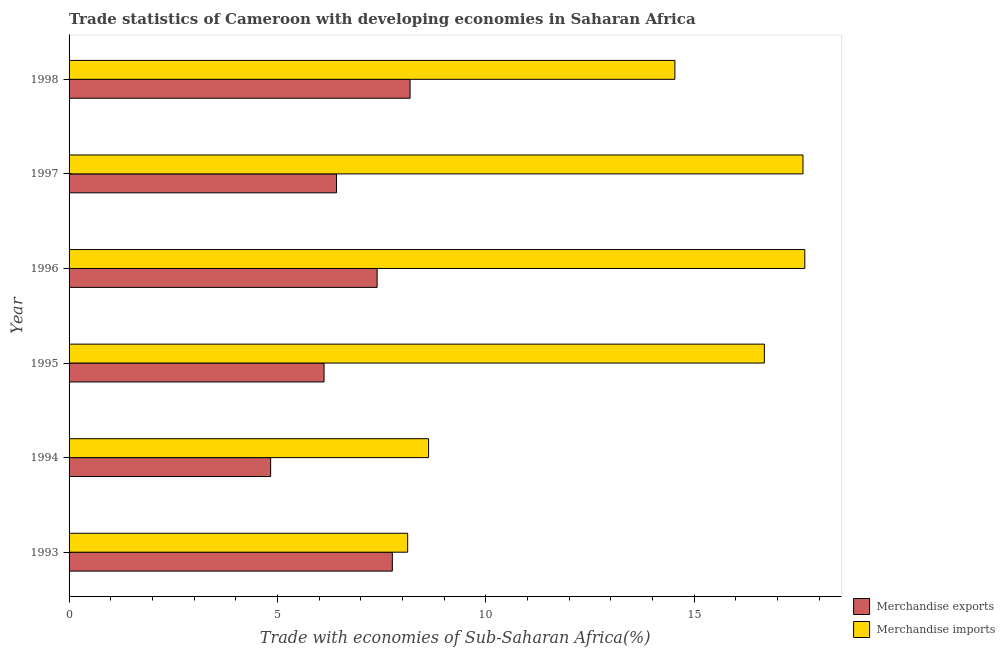How many different coloured bars are there?
Offer a very short reply. 2. How many groups of bars are there?
Ensure brevity in your answer.  6. Are the number of bars per tick equal to the number of legend labels?
Offer a very short reply. Yes. Are the number of bars on each tick of the Y-axis equal?
Provide a short and direct response. Yes. What is the label of the 2nd group of bars from the top?
Your answer should be very brief. 1997. In how many cases, is the number of bars for a given year not equal to the number of legend labels?
Keep it short and to the point. 0. What is the merchandise imports in 1998?
Offer a terse response. 14.53. Across all years, what is the maximum merchandise imports?
Your response must be concise. 17.65. Across all years, what is the minimum merchandise imports?
Your answer should be compact. 8.12. In which year was the merchandise exports minimum?
Keep it short and to the point. 1994. What is the total merchandise imports in the graph?
Keep it short and to the point. 83.23. What is the difference between the merchandise exports in 1996 and that in 1998?
Give a very brief answer. -0.79. What is the difference between the merchandise exports in 1993 and the merchandise imports in 1994?
Your answer should be very brief. -0.87. What is the average merchandise imports per year?
Your answer should be compact. 13.87. In the year 1995, what is the difference between the merchandise imports and merchandise exports?
Make the answer very short. 10.56. In how many years, is the merchandise imports greater than 15 %?
Your answer should be compact. 3. What is the ratio of the merchandise imports in 1997 to that in 1998?
Offer a very short reply. 1.21. Is the merchandise exports in 1993 less than that in 1994?
Ensure brevity in your answer.  No. Is the difference between the merchandise exports in 1995 and 1996 greater than the difference between the merchandise imports in 1995 and 1996?
Provide a succinct answer. No. What is the difference between the highest and the second highest merchandise exports?
Your response must be concise. 0.43. What is the difference between the highest and the lowest merchandise exports?
Keep it short and to the point. 3.35. In how many years, is the merchandise exports greater than the average merchandise exports taken over all years?
Ensure brevity in your answer.  3. What does the 1st bar from the top in 1998 represents?
Provide a short and direct response. Merchandise imports. What does the 2nd bar from the bottom in 1996 represents?
Keep it short and to the point. Merchandise imports. Are all the bars in the graph horizontal?
Your response must be concise. Yes. How many legend labels are there?
Your answer should be compact. 2. What is the title of the graph?
Your answer should be very brief. Trade statistics of Cameroon with developing economies in Saharan Africa. Does "Attending school" appear as one of the legend labels in the graph?
Provide a succinct answer. No. What is the label or title of the X-axis?
Ensure brevity in your answer.  Trade with economies of Sub-Saharan Africa(%). What is the Trade with economies of Sub-Saharan Africa(%) in Merchandise exports in 1993?
Ensure brevity in your answer.  7.76. What is the Trade with economies of Sub-Saharan Africa(%) in Merchandise imports in 1993?
Your response must be concise. 8.12. What is the Trade with economies of Sub-Saharan Africa(%) of Merchandise exports in 1994?
Offer a very short reply. 4.84. What is the Trade with economies of Sub-Saharan Africa(%) of Merchandise imports in 1994?
Your response must be concise. 8.63. What is the Trade with economies of Sub-Saharan Africa(%) in Merchandise exports in 1995?
Offer a terse response. 6.12. What is the Trade with economies of Sub-Saharan Africa(%) of Merchandise imports in 1995?
Make the answer very short. 16.68. What is the Trade with economies of Sub-Saharan Africa(%) in Merchandise exports in 1996?
Provide a short and direct response. 7.39. What is the Trade with economies of Sub-Saharan Africa(%) in Merchandise imports in 1996?
Provide a succinct answer. 17.65. What is the Trade with economies of Sub-Saharan Africa(%) of Merchandise exports in 1997?
Provide a short and direct response. 6.42. What is the Trade with economies of Sub-Saharan Africa(%) in Merchandise imports in 1997?
Provide a short and direct response. 17.61. What is the Trade with economies of Sub-Saharan Africa(%) in Merchandise exports in 1998?
Offer a terse response. 8.18. What is the Trade with economies of Sub-Saharan Africa(%) in Merchandise imports in 1998?
Offer a terse response. 14.53. Across all years, what is the maximum Trade with economies of Sub-Saharan Africa(%) in Merchandise exports?
Offer a terse response. 8.18. Across all years, what is the maximum Trade with economies of Sub-Saharan Africa(%) in Merchandise imports?
Offer a very short reply. 17.65. Across all years, what is the minimum Trade with economies of Sub-Saharan Africa(%) in Merchandise exports?
Your response must be concise. 4.84. Across all years, what is the minimum Trade with economies of Sub-Saharan Africa(%) in Merchandise imports?
Your answer should be compact. 8.12. What is the total Trade with economies of Sub-Saharan Africa(%) in Merchandise exports in the graph?
Your answer should be very brief. 40.7. What is the total Trade with economies of Sub-Saharan Africa(%) in Merchandise imports in the graph?
Provide a short and direct response. 83.23. What is the difference between the Trade with economies of Sub-Saharan Africa(%) of Merchandise exports in 1993 and that in 1994?
Your answer should be compact. 2.92. What is the difference between the Trade with economies of Sub-Saharan Africa(%) in Merchandise imports in 1993 and that in 1994?
Offer a terse response. -0.5. What is the difference between the Trade with economies of Sub-Saharan Africa(%) of Merchandise exports in 1993 and that in 1995?
Provide a short and direct response. 1.64. What is the difference between the Trade with economies of Sub-Saharan Africa(%) of Merchandise imports in 1993 and that in 1995?
Provide a short and direct response. -8.56. What is the difference between the Trade with economies of Sub-Saharan Africa(%) in Merchandise exports in 1993 and that in 1996?
Provide a short and direct response. 0.37. What is the difference between the Trade with economies of Sub-Saharan Africa(%) in Merchandise imports in 1993 and that in 1996?
Give a very brief answer. -9.53. What is the difference between the Trade with economies of Sub-Saharan Africa(%) in Merchandise exports in 1993 and that in 1997?
Offer a very short reply. 1.34. What is the difference between the Trade with economies of Sub-Saharan Africa(%) in Merchandise imports in 1993 and that in 1997?
Give a very brief answer. -9.48. What is the difference between the Trade with economies of Sub-Saharan Africa(%) of Merchandise exports in 1993 and that in 1998?
Keep it short and to the point. -0.43. What is the difference between the Trade with economies of Sub-Saharan Africa(%) in Merchandise imports in 1993 and that in 1998?
Provide a succinct answer. -6.41. What is the difference between the Trade with economies of Sub-Saharan Africa(%) in Merchandise exports in 1994 and that in 1995?
Offer a very short reply. -1.28. What is the difference between the Trade with economies of Sub-Saharan Africa(%) in Merchandise imports in 1994 and that in 1995?
Provide a succinct answer. -8.06. What is the difference between the Trade with economies of Sub-Saharan Africa(%) in Merchandise exports in 1994 and that in 1996?
Offer a terse response. -2.55. What is the difference between the Trade with economies of Sub-Saharan Africa(%) of Merchandise imports in 1994 and that in 1996?
Your answer should be compact. -9.03. What is the difference between the Trade with economies of Sub-Saharan Africa(%) of Merchandise exports in 1994 and that in 1997?
Offer a very short reply. -1.58. What is the difference between the Trade with economies of Sub-Saharan Africa(%) of Merchandise imports in 1994 and that in 1997?
Provide a succinct answer. -8.98. What is the difference between the Trade with economies of Sub-Saharan Africa(%) of Merchandise exports in 1994 and that in 1998?
Your answer should be very brief. -3.35. What is the difference between the Trade with economies of Sub-Saharan Africa(%) of Merchandise imports in 1994 and that in 1998?
Give a very brief answer. -5.91. What is the difference between the Trade with economies of Sub-Saharan Africa(%) in Merchandise exports in 1995 and that in 1996?
Provide a succinct answer. -1.27. What is the difference between the Trade with economies of Sub-Saharan Africa(%) of Merchandise imports in 1995 and that in 1996?
Ensure brevity in your answer.  -0.97. What is the difference between the Trade with economies of Sub-Saharan Africa(%) of Merchandise exports in 1995 and that in 1997?
Your answer should be compact. -0.3. What is the difference between the Trade with economies of Sub-Saharan Africa(%) of Merchandise imports in 1995 and that in 1997?
Provide a short and direct response. -0.93. What is the difference between the Trade with economies of Sub-Saharan Africa(%) in Merchandise exports in 1995 and that in 1998?
Offer a terse response. -2.06. What is the difference between the Trade with economies of Sub-Saharan Africa(%) of Merchandise imports in 1995 and that in 1998?
Offer a very short reply. 2.15. What is the difference between the Trade with economies of Sub-Saharan Africa(%) of Merchandise exports in 1996 and that in 1997?
Keep it short and to the point. 0.97. What is the difference between the Trade with economies of Sub-Saharan Africa(%) in Merchandise imports in 1996 and that in 1997?
Provide a short and direct response. 0.04. What is the difference between the Trade with economies of Sub-Saharan Africa(%) in Merchandise exports in 1996 and that in 1998?
Your answer should be very brief. -0.79. What is the difference between the Trade with economies of Sub-Saharan Africa(%) in Merchandise imports in 1996 and that in 1998?
Keep it short and to the point. 3.12. What is the difference between the Trade with economies of Sub-Saharan Africa(%) of Merchandise exports in 1997 and that in 1998?
Give a very brief answer. -1.77. What is the difference between the Trade with economies of Sub-Saharan Africa(%) in Merchandise imports in 1997 and that in 1998?
Your response must be concise. 3.07. What is the difference between the Trade with economies of Sub-Saharan Africa(%) of Merchandise exports in 1993 and the Trade with economies of Sub-Saharan Africa(%) of Merchandise imports in 1994?
Keep it short and to the point. -0.87. What is the difference between the Trade with economies of Sub-Saharan Africa(%) of Merchandise exports in 1993 and the Trade with economies of Sub-Saharan Africa(%) of Merchandise imports in 1995?
Your answer should be compact. -8.93. What is the difference between the Trade with economies of Sub-Saharan Africa(%) of Merchandise exports in 1993 and the Trade with economies of Sub-Saharan Africa(%) of Merchandise imports in 1996?
Offer a terse response. -9.9. What is the difference between the Trade with economies of Sub-Saharan Africa(%) in Merchandise exports in 1993 and the Trade with economies of Sub-Saharan Africa(%) in Merchandise imports in 1997?
Give a very brief answer. -9.85. What is the difference between the Trade with economies of Sub-Saharan Africa(%) of Merchandise exports in 1993 and the Trade with economies of Sub-Saharan Africa(%) of Merchandise imports in 1998?
Give a very brief answer. -6.78. What is the difference between the Trade with economies of Sub-Saharan Africa(%) of Merchandise exports in 1994 and the Trade with economies of Sub-Saharan Africa(%) of Merchandise imports in 1995?
Your answer should be compact. -11.85. What is the difference between the Trade with economies of Sub-Saharan Africa(%) of Merchandise exports in 1994 and the Trade with economies of Sub-Saharan Africa(%) of Merchandise imports in 1996?
Make the answer very short. -12.82. What is the difference between the Trade with economies of Sub-Saharan Africa(%) in Merchandise exports in 1994 and the Trade with economies of Sub-Saharan Africa(%) in Merchandise imports in 1997?
Give a very brief answer. -12.77. What is the difference between the Trade with economies of Sub-Saharan Africa(%) in Merchandise exports in 1994 and the Trade with economies of Sub-Saharan Africa(%) in Merchandise imports in 1998?
Give a very brief answer. -9.7. What is the difference between the Trade with economies of Sub-Saharan Africa(%) of Merchandise exports in 1995 and the Trade with economies of Sub-Saharan Africa(%) of Merchandise imports in 1996?
Provide a succinct answer. -11.53. What is the difference between the Trade with economies of Sub-Saharan Africa(%) in Merchandise exports in 1995 and the Trade with economies of Sub-Saharan Africa(%) in Merchandise imports in 1997?
Your answer should be compact. -11.49. What is the difference between the Trade with economies of Sub-Saharan Africa(%) of Merchandise exports in 1995 and the Trade with economies of Sub-Saharan Africa(%) of Merchandise imports in 1998?
Your response must be concise. -8.42. What is the difference between the Trade with economies of Sub-Saharan Africa(%) in Merchandise exports in 1996 and the Trade with economies of Sub-Saharan Africa(%) in Merchandise imports in 1997?
Provide a succinct answer. -10.22. What is the difference between the Trade with economies of Sub-Saharan Africa(%) of Merchandise exports in 1996 and the Trade with economies of Sub-Saharan Africa(%) of Merchandise imports in 1998?
Keep it short and to the point. -7.14. What is the difference between the Trade with economies of Sub-Saharan Africa(%) in Merchandise exports in 1997 and the Trade with economies of Sub-Saharan Africa(%) in Merchandise imports in 1998?
Provide a succinct answer. -8.12. What is the average Trade with economies of Sub-Saharan Africa(%) in Merchandise exports per year?
Make the answer very short. 6.78. What is the average Trade with economies of Sub-Saharan Africa(%) of Merchandise imports per year?
Keep it short and to the point. 13.87. In the year 1993, what is the difference between the Trade with economies of Sub-Saharan Africa(%) in Merchandise exports and Trade with economies of Sub-Saharan Africa(%) in Merchandise imports?
Your answer should be very brief. -0.37. In the year 1994, what is the difference between the Trade with economies of Sub-Saharan Africa(%) of Merchandise exports and Trade with economies of Sub-Saharan Africa(%) of Merchandise imports?
Provide a succinct answer. -3.79. In the year 1995, what is the difference between the Trade with economies of Sub-Saharan Africa(%) in Merchandise exports and Trade with economies of Sub-Saharan Africa(%) in Merchandise imports?
Offer a terse response. -10.56. In the year 1996, what is the difference between the Trade with economies of Sub-Saharan Africa(%) of Merchandise exports and Trade with economies of Sub-Saharan Africa(%) of Merchandise imports?
Make the answer very short. -10.26. In the year 1997, what is the difference between the Trade with economies of Sub-Saharan Africa(%) in Merchandise exports and Trade with economies of Sub-Saharan Africa(%) in Merchandise imports?
Your response must be concise. -11.19. In the year 1998, what is the difference between the Trade with economies of Sub-Saharan Africa(%) in Merchandise exports and Trade with economies of Sub-Saharan Africa(%) in Merchandise imports?
Offer a terse response. -6.35. What is the ratio of the Trade with economies of Sub-Saharan Africa(%) of Merchandise exports in 1993 to that in 1994?
Provide a succinct answer. 1.6. What is the ratio of the Trade with economies of Sub-Saharan Africa(%) of Merchandise imports in 1993 to that in 1994?
Ensure brevity in your answer.  0.94. What is the ratio of the Trade with economies of Sub-Saharan Africa(%) in Merchandise exports in 1993 to that in 1995?
Provide a succinct answer. 1.27. What is the ratio of the Trade with economies of Sub-Saharan Africa(%) in Merchandise imports in 1993 to that in 1995?
Offer a terse response. 0.49. What is the ratio of the Trade with economies of Sub-Saharan Africa(%) in Merchandise exports in 1993 to that in 1996?
Ensure brevity in your answer.  1.05. What is the ratio of the Trade with economies of Sub-Saharan Africa(%) of Merchandise imports in 1993 to that in 1996?
Offer a terse response. 0.46. What is the ratio of the Trade with economies of Sub-Saharan Africa(%) of Merchandise exports in 1993 to that in 1997?
Your response must be concise. 1.21. What is the ratio of the Trade with economies of Sub-Saharan Africa(%) in Merchandise imports in 1993 to that in 1997?
Offer a very short reply. 0.46. What is the ratio of the Trade with economies of Sub-Saharan Africa(%) of Merchandise exports in 1993 to that in 1998?
Provide a succinct answer. 0.95. What is the ratio of the Trade with economies of Sub-Saharan Africa(%) in Merchandise imports in 1993 to that in 1998?
Offer a very short reply. 0.56. What is the ratio of the Trade with economies of Sub-Saharan Africa(%) of Merchandise exports in 1994 to that in 1995?
Give a very brief answer. 0.79. What is the ratio of the Trade with economies of Sub-Saharan Africa(%) of Merchandise imports in 1994 to that in 1995?
Keep it short and to the point. 0.52. What is the ratio of the Trade with economies of Sub-Saharan Africa(%) of Merchandise exports in 1994 to that in 1996?
Keep it short and to the point. 0.65. What is the ratio of the Trade with economies of Sub-Saharan Africa(%) of Merchandise imports in 1994 to that in 1996?
Your response must be concise. 0.49. What is the ratio of the Trade with economies of Sub-Saharan Africa(%) in Merchandise exports in 1994 to that in 1997?
Offer a terse response. 0.75. What is the ratio of the Trade with economies of Sub-Saharan Africa(%) of Merchandise imports in 1994 to that in 1997?
Keep it short and to the point. 0.49. What is the ratio of the Trade with economies of Sub-Saharan Africa(%) of Merchandise exports in 1994 to that in 1998?
Your answer should be very brief. 0.59. What is the ratio of the Trade with economies of Sub-Saharan Africa(%) in Merchandise imports in 1994 to that in 1998?
Your response must be concise. 0.59. What is the ratio of the Trade with economies of Sub-Saharan Africa(%) in Merchandise exports in 1995 to that in 1996?
Make the answer very short. 0.83. What is the ratio of the Trade with economies of Sub-Saharan Africa(%) in Merchandise imports in 1995 to that in 1996?
Offer a terse response. 0.94. What is the ratio of the Trade with economies of Sub-Saharan Africa(%) of Merchandise exports in 1995 to that in 1997?
Keep it short and to the point. 0.95. What is the ratio of the Trade with economies of Sub-Saharan Africa(%) of Merchandise exports in 1995 to that in 1998?
Give a very brief answer. 0.75. What is the ratio of the Trade with economies of Sub-Saharan Africa(%) of Merchandise imports in 1995 to that in 1998?
Your response must be concise. 1.15. What is the ratio of the Trade with economies of Sub-Saharan Africa(%) of Merchandise exports in 1996 to that in 1997?
Ensure brevity in your answer.  1.15. What is the ratio of the Trade with economies of Sub-Saharan Africa(%) in Merchandise exports in 1996 to that in 1998?
Your response must be concise. 0.9. What is the ratio of the Trade with economies of Sub-Saharan Africa(%) of Merchandise imports in 1996 to that in 1998?
Ensure brevity in your answer.  1.21. What is the ratio of the Trade with economies of Sub-Saharan Africa(%) in Merchandise exports in 1997 to that in 1998?
Offer a terse response. 0.78. What is the ratio of the Trade with economies of Sub-Saharan Africa(%) in Merchandise imports in 1997 to that in 1998?
Offer a very short reply. 1.21. What is the difference between the highest and the second highest Trade with economies of Sub-Saharan Africa(%) of Merchandise exports?
Your answer should be compact. 0.43. What is the difference between the highest and the second highest Trade with economies of Sub-Saharan Africa(%) of Merchandise imports?
Offer a very short reply. 0.04. What is the difference between the highest and the lowest Trade with economies of Sub-Saharan Africa(%) of Merchandise exports?
Make the answer very short. 3.35. What is the difference between the highest and the lowest Trade with economies of Sub-Saharan Africa(%) of Merchandise imports?
Your answer should be compact. 9.53. 